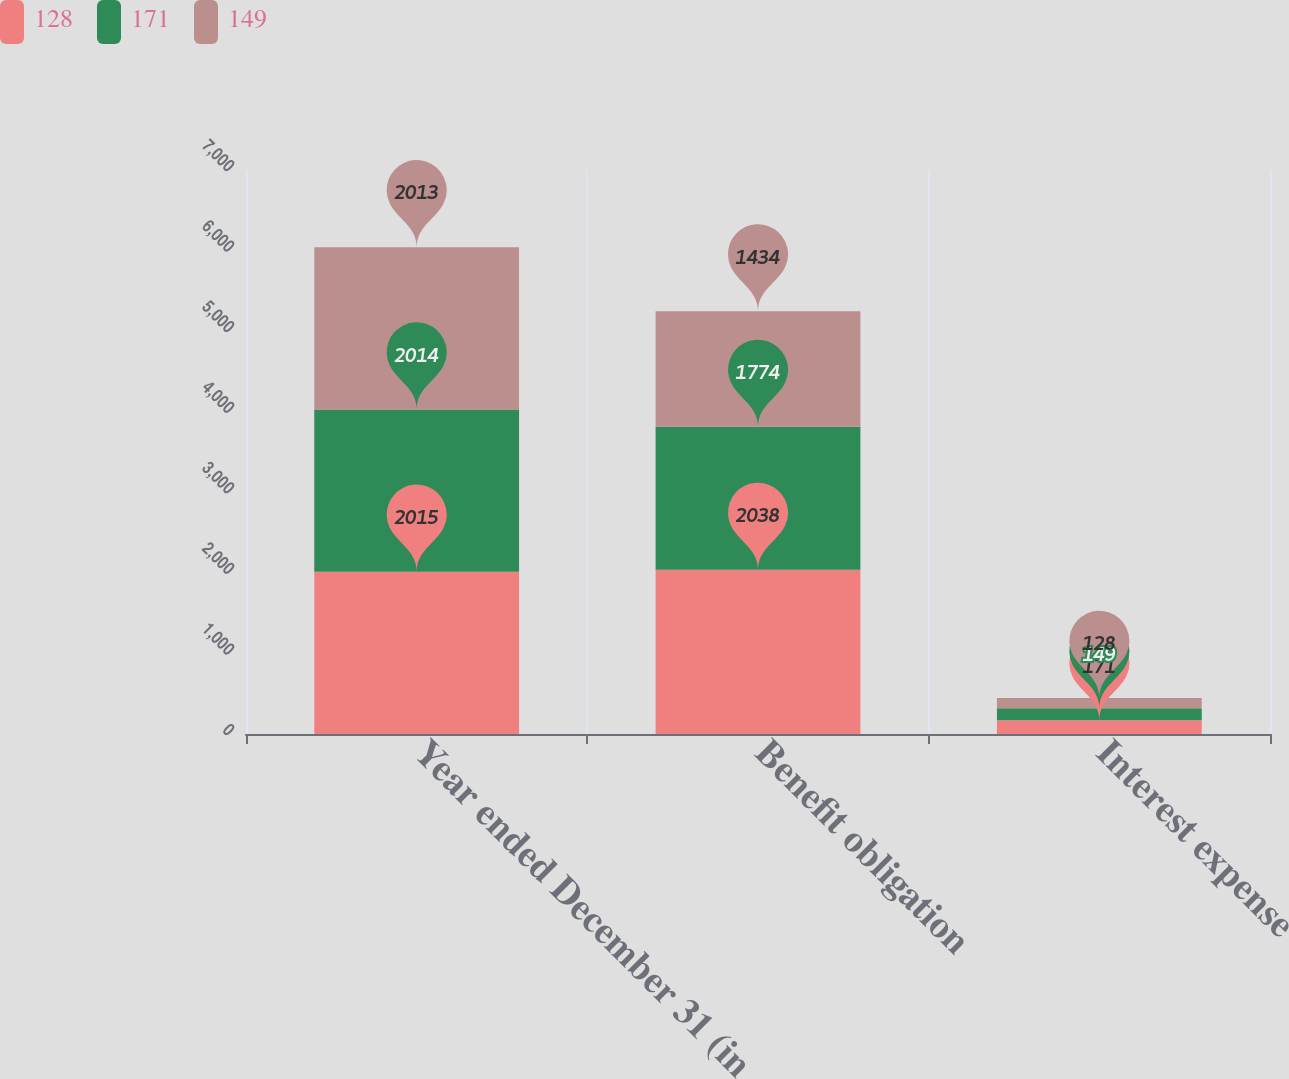Convert chart. <chart><loc_0><loc_0><loc_500><loc_500><stacked_bar_chart><ecel><fcel>Year ended December 31 (in<fcel>Benefit obligation<fcel>Interest expense<nl><fcel>128<fcel>2015<fcel>2038<fcel>171<nl><fcel>171<fcel>2014<fcel>1774<fcel>149<nl><fcel>149<fcel>2013<fcel>1434<fcel>128<nl></chart> 